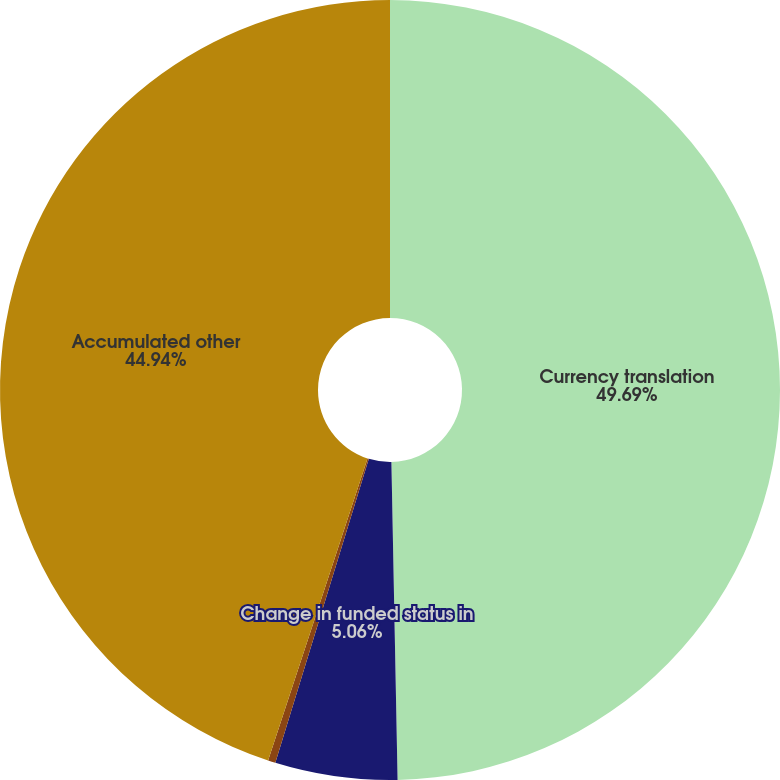<chart> <loc_0><loc_0><loc_500><loc_500><pie_chart><fcel>Currency translation<fcel>Change in funded status in<fcel>Pension and postretirement<fcel>Accumulated other<nl><fcel>49.69%<fcel>5.06%<fcel>0.31%<fcel>44.94%<nl></chart> 